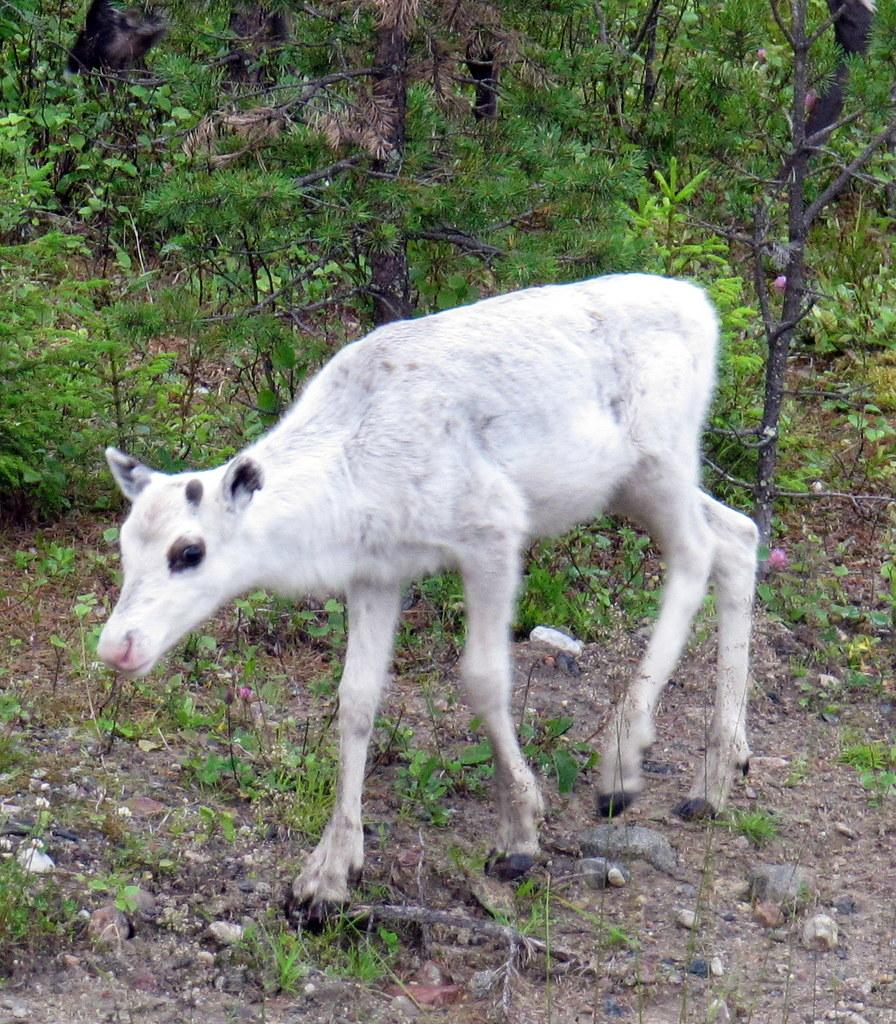What type of animal is in the image? There is a white-colored calf in the image. What can be seen in the background of the image? There are plants in the background of the image. What is visible at the bottom of the image? There are stones visible at the bottom of the image. Can you see the calf's toes in the image? The image does not show the calf's toes, as it only shows the calf's body and not its feet. 